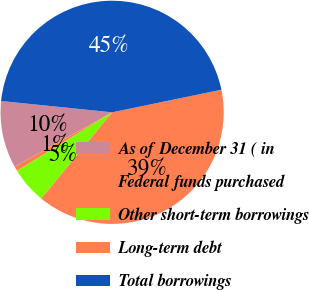<chart> <loc_0><loc_0><loc_500><loc_500><pie_chart><fcel>As of December 31 ( in<fcel>Federal funds purchased<fcel>Other short-term borrowings<fcel>Long-term debt<fcel>Total borrowings<nl><fcel>9.72%<fcel>0.68%<fcel>5.28%<fcel>39.18%<fcel>45.14%<nl></chart> 